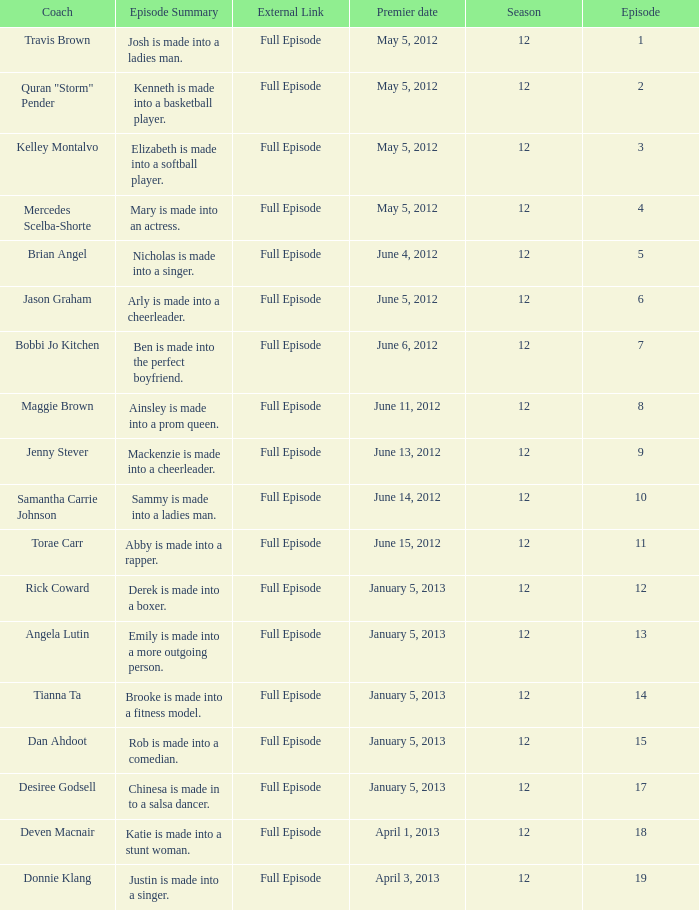Name the episode for travis brown 1.0. 